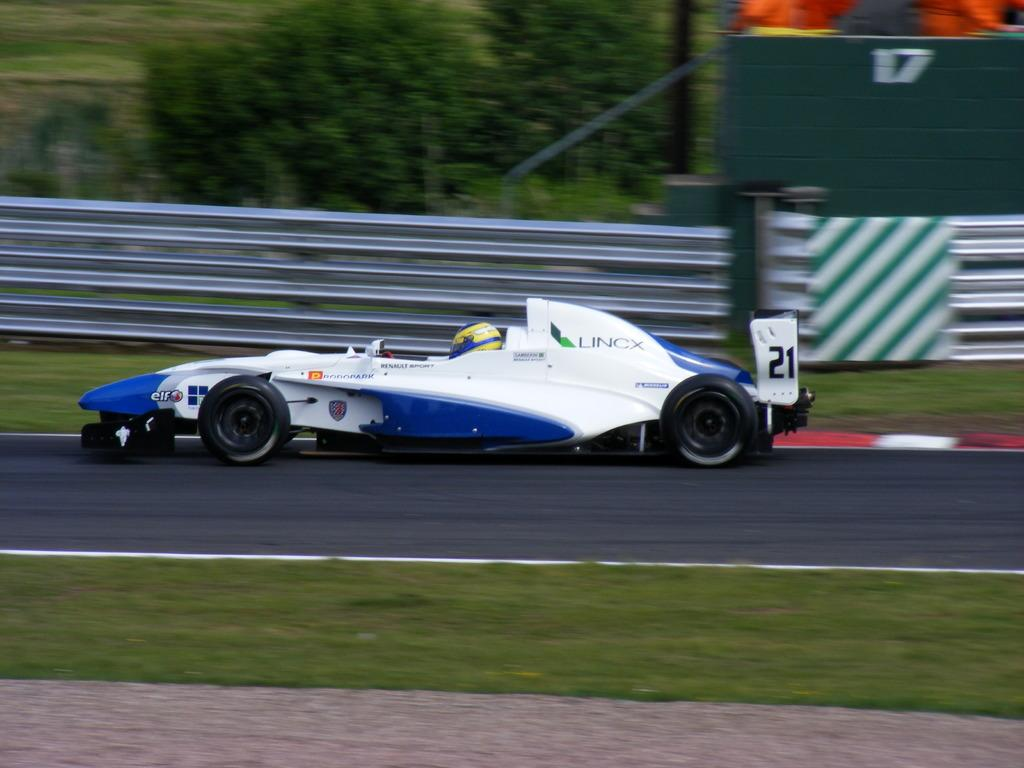What is the person in the image doing? There is a person riding a car in the image. What can be seen on the sides of the road in the image? Grass and trees are visible on the roadsides in the image. What type of voice can be heard coming from the camp in the image? There is no camp present in the image, so it's not possible to determine what, if any, voice might be heard. 